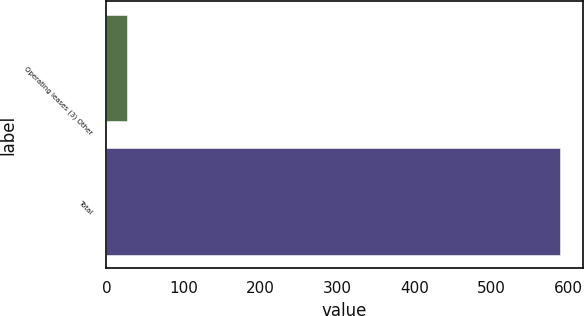Convert chart. <chart><loc_0><loc_0><loc_500><loc_500><bar_chart><fcel>Operating leases (3) Other<fcel>Total<nl><fcel>26.6<fcel>589<nl></chart> 